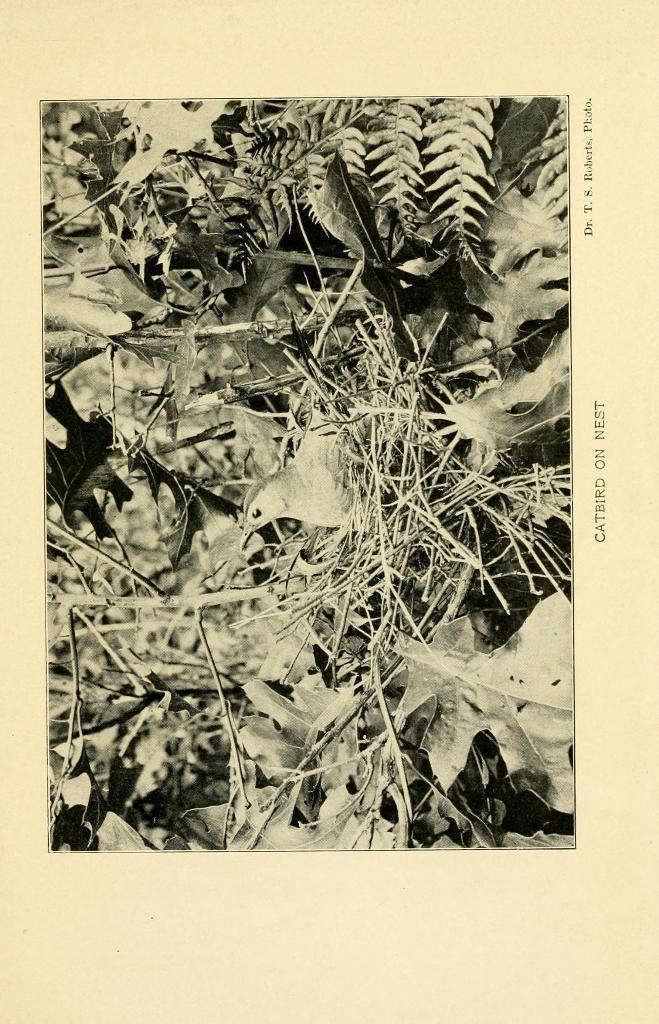Please provide a concise description of this image. Here in this picture we can see a photograph present on the paper over there and in that photograph we can see a bird present in a nest which is present on the tree over there. 